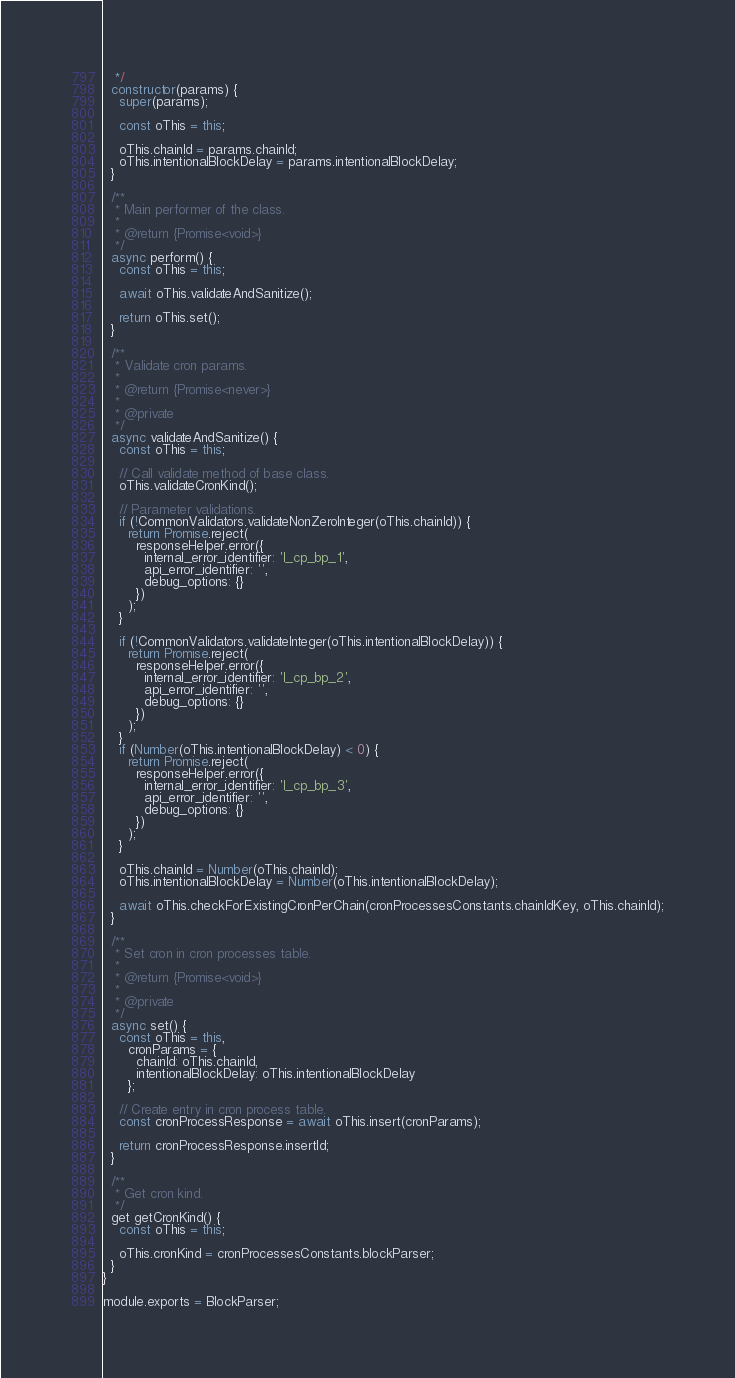Convert code to text. <code><loc_0><loc_0><loc_500><loc_500><_JavaScript_>   */
  constructor(params) {
    super(params);

    const oThis = this;

    oThis.chainId = params.chainId;
    oThis.intentionalBlockDelay = params.intentionalBlockDelay;
  }

  /**
   * Main performer of the class.
   *
   * @return {Promise<void>}
   */
  async perform() {
    const oThis = this;

    await oThis.validateAndSanitize();

    return oThis.set();
  }

  /**
   * Validate cron params.
   *
   * @return {Promise<never>}
   *
   * @private
   */
  async validateAndSanitize() {
    const oThis = this;

    // Call validate method of base class.
    oThis.validateCronKind();

    // Parameter validations.
    if (!CommonValidators.validateNonZeroInteger(oThis.chainId)) {
      return Promise.reject(
        responseHelper.error({
          internal_error_identifier: 'l_cp_bp_1',
          api_error_identifier: '',
          debug_options: {}
        })
      );
    }

    if (!CommonValidators.validateInteger(oThis.intentionalBlockDelay)) {
      return Promise.reject(
        responseHelper.error({
          internal_error_identifier: 'l_cp_bp_2',
          api_error_identifier: '',
          debug_options: {}
        })
      );
    }
    if (Number(oThis.intentionalBlockDelay) < 0) {
      return Promise.reject(
        responseHelper.error({
          internal_error_identifier: 'l_cp_bp_3',
          api_error_identifier: '',
          debug_options: {}
        })
      );
    }

    oThis.chainId = Number(oThis.chainId);
    oThis.intentionalBlockDelay = Number(oThis.intentionalBlockDelay);

    await oThis.checkForExistingCronPerChain(cronProcessesConstants.chainIdKey, oThis.chainId);
  }

  /**
   * Set cron in cron processes table.
   *
   * @return {Promise<void>}
   *
   * @private
   */
  async set() {
    const oThis = this,
      cronParams = {
        chainId: oThis.chainId,
        intentionalBlockDelay: oThis.intentionalBlockDelay
      };

    // Create entry in cron process table.
    const cronProcessResponse = await oThis.insert(cronParams);

    return cronProcessResponse.insertId;
  }

  /**
   * Get cron kind.
   */
  get getCronKind() {
    const oThis = this;

    oThis.cronKind = cronProcessesConstants.blockParser;
  }
}

module.exports = BlockParser;
</code> 